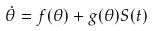<formula> <loc_0><loc_0><loc_500><loc_500>\dot { \theta } = f ( \theta ) + g ( \theta ) S ( t )</formula> 